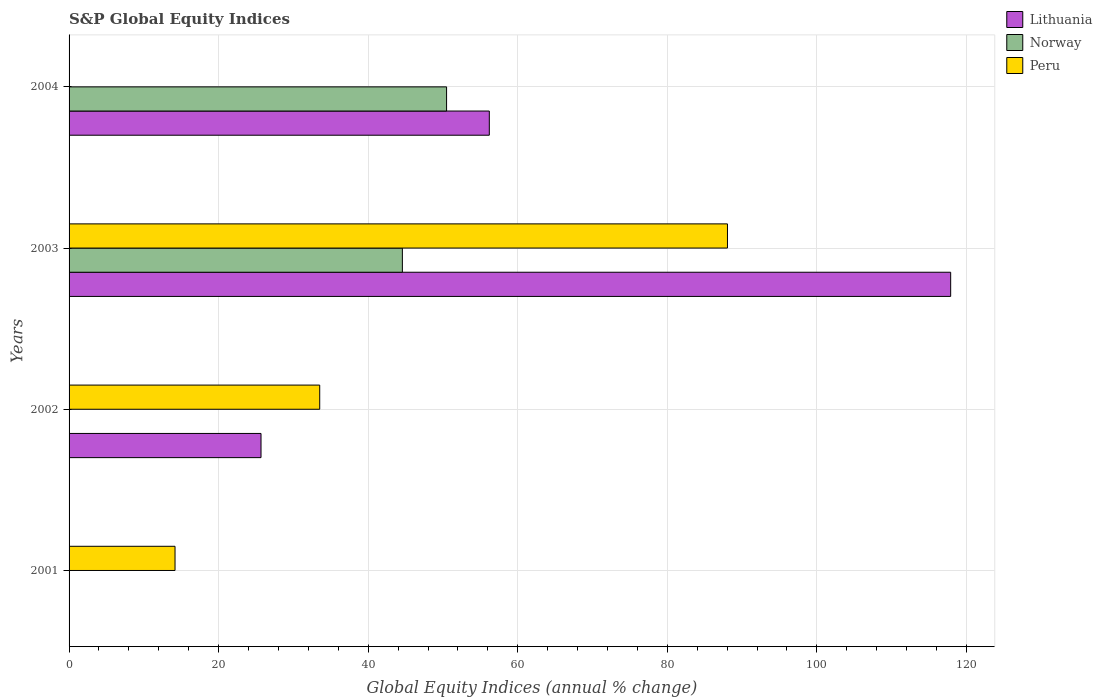Are the number of bars on each tick of the Y-axis equal?
Offer a very short reply. No. How many bars are there on the 3rd tick from the top?
Provide a short and direct response. 2. How many bars are there on the 1st tick from the bottom?
Keep it short and to the point. 1. In how many cases, is the number of bars for a given year not equal to the number of legend labels?
Give a very brief answer. 3. What is the global equity indices in Peru in 2001?
Your answer should be very brief. 14.17. Across all years, what is the maximum global equity indices in Lithuania?
Keep it short and to the point. 117.9. In which year was the global equity indices in Peru maximum?
Your answer should be very brief. 2003. What is the total global equity indices in Lithuania in the graph?
Your answer should be very brief. 199.77. What is the difference between the global equity indices in Peru in 2001 and that in 2002?
Provide a short and direct response. -19.35. What is the difference between the global equity indices in Norway in 2003 and the global equity indices in Lithuania in 2002?
Your response must be concise. 18.9. What is the average global equity indices in Peru per year?
Provide a short and direct response. 33.93. In the year 2003, what is the difference between the global equity indices in Norway and global equity indices in Lithuania?
Offer a very short reply. -73.33. Is the global equity indices in Peru in 2002 less than that in 2003?
Keep it short and to the point. Yes. What is the difference between the highest and the second highest global equity indices in Lithuania?
Your answer should be very brief. 61.7. What is the difference between the highest and the lowest global equity indices in Peru?
Your response must be concise. 88.05. In how many years, is the global equity indices in Norway greater than the average global equity indices in Norway taken over all years?
Keep it short and to the point. 2. Is the sum of the global equity indices in Peru in 2002 and 2003 greater than the maximum global equity indices in Lithuania across all years?
Make the answer very short. Yes. How many bars are there?
Offer a very short reply. 8. What is the difference between two consecutive major ticks on the X-axis?
Ensure brevity in your answer.  20. Does the graph contain any zero values?
Provide a succinct answer. Yes. Does the graph contain grids?
Make the answer very short. Yes. Where does the legend appear in the graph?
Give a very brief answer. Top right. How many legend labels are there?
Your answer should be compact. 3. How are the legend labels stacked?
Offer a terse response. Vertical. What is the title of the graph?
Provide a short and direct response. S&P Global Equity Indices. Does "Cuba" appear as one of the legend labels in the graph?
Your response must be concise. No. What is the label or title of the X-axis?
Your answer should be compact. Global Equity Indices (annual % change). What is the Global Equity Indices (annual % change) of Lithuania in 2001?
Keep it short and to the point. 0. What is the Global Equity Indices (annual % change) of Peru in 2001?
Offer a very short reply. 14.17. What is the Global Equity Indices (annual % change) of Lithuania in 2002?
Provide a short and direct response. 25.67. What is the Global Equity Indices (annual % change) in Norway in 2002?
Your response must be concise. 0. What is the Global Equity Indices (annual % change) in Peru in 2002?
Your response must be concise. 33.52. What is the Global Equity Indices (annual % change) of Lithuania in 2003?
Provide a succinct answer. 117.9. What is the Global Equity Indices (annual % change) in Norway in 2003?
Offer a very short reply. 44.57. What is the Global Equity Indices (annual % change) in Peru in 2003?
Provide a succinct answer. 88.05. What is the Global Equity Indices (annual % change) in Lithuania in 2004?
Give a very brief answer. 56.2. What is the Global Equity Indices (annual % change) of Norway in 2004?
Keep it short and to the point. 50.49. What is the Global Equity Indices (annual % change) in Peru in 2004?
Give a very brief answer. 0. Across all years, what is the maximum Global Equity Indices (annual % change) of Lithuania?
Your response must be concise. 117.9. Across all years, what is the maximum Global Equity Indices (annual % change) in Norway?
Offer a terse response. 50.49. Across all years, what is the maximum Global Equity Indices (annual % change) of Peru?
Provide a succinct answer. 88.05. Across all years, what is the minimum Global Equity Indices (annual % change) of Lithuania?
Offer a very short reply. 0. Across all years, what is the minimum Global Equity Indices (annual % change) of Peru?
Provide a short and direct response. 0. What is the total Global Equity Indices (annual % change) in Lithuania in the graph?
Provide a short and direct response. 199.77. What is the total Global Equity Indices (annual % change) of Norway in the graph?
Provide a succinct answer. 95.06. What is the total Global Equity Indices (annual % change) in Peru in the graph?
Your response must be concise. 135.74. What is the difference between the Global Equity Indices (annual % change) in Peru in 2001 and that in 2002?
Offer a very short reply. -19.35. What is the difference between the Global Equity Indices (annual % change) of Peru in 2001 and that in 2003?
Your response must be concise. -73.88. What is the difference between the Global Equity Indices (annual % change) in Lithuania in 2002 and that in 2003?
Give a very brief answer. -92.23. What is the difference between the Global Equity Indices (annual % change) in Peru in 2002 and that in 2003?
Give a very brief answer. -54.53. What is the difference between the Global Equity Indices (annual % change) of Lithuania in 2002 and that in 2004?
Your answer should be compact. -30.53. What is the difference between the Global Equity Indices (annual % change) in Lithuania in 2003 and that in 2004?
Your answer should be compact. 61.7. What is the difference between the Global Equity Indices (annual % change) of Norway in 2003 and that in 2004?
Offer a terse response. -5.91. What is the difference between the Global Equity Indices (annual % change) in Lithuania in 2002 and the Global Equity Indices (annual % change) in Norway in 2003?
Give a very brief answer. -18.9. What is the difference between the Global Equity Indices (annual % change) in Lithuania in 2002 and the Global Equity Indices (annual % change) in Peru in 2003?
Offer a very short reply. -62.38. What is the difference between the Global Equity Indices (annual % change) in Lithuania in 2002 and the Global Equity Indices (annual % change) in Norway in 2004?
Your response must be concise. -24.82. What is the difference between the Global Equity Indices (annual % change) in Lithuania in 2003 and the Global Equity Indices (annual % change) in Norway in 2004?
Offer a terse response. 67.41. What is the average Global Equity Indices (annual % change) of Lithuania per year?
Provide a short and direct response. 49.94. What is the average Global Equity Indices (annual % change) in Norway per year?
Your answer should be compact. 23.77. What is the average Global Equity Indices (annual % change) in Peru per year?
Your answer should be compact. 33.93. In the year 2002, what is the difference between the Global Equity Indices (annual % change) of Lithuania and Global Equity Indices (annual % change) of Peru?
Give a very brief answer. -7.85. In the year 2003, what is the difference between the Global Equity Indices (annual % change) of Lithuania and Global Equity Indices (annual % change) of Norway?
Offer a terse response. 73.33. In the year 2003, what is the difference between the Global Equity Indices (annual % change) of Lithuania and Global Equity Indices (annual % change) of Peru?
Ensure brevity in your answer.  29.85. In the year 2003, what is the difference between the Global Equity Indices (annual % change) of Norway and Global Equity Indices (annual % change) of Peru?
Your answer should be very brief. -43.48. In the year 2004, what is the difference between the Global Equity Indices (annual % change) of Lithuania and Global Equity Indices (annual % change) of Norway?
Offer a terse response. 5.71. What is the ratio of the Global Equity Indices (annual % change) of Peru in 2001 to that in 2002?
Provide a succinct answer. 0.42. What is the ratio of the Global Equity Indices (annual % change) of Peru in 2001 to that in 2003?
Make the answer very short. 0.16. What is the ratio of the Global Equity Indices (annual % change) in Lithuania in 2002 to that in 2003?
Your answer should be very brief. 0.22. What is the ratio of the Global Equity Indices (annual % change) of Peru in 2002 to that in 2003?
Keep it short and to the point. 0.38. What is the ratio of the Global Equity Indices (annual % change) of Lithuania in 2002 to that in 2004?
Provide a short and direct response. 0.46. What is the ratio of the Global Equity Indices (annual % change) in Lithuania in 2003 to that in 2004?
Offer a very short reply. 2.1. What is the ratio of the Global Equity Indices (annual % change) of Norway in 2003 to that in 2004?
Your answer should be very brief. 0.88. What is the difference between the highest and the second highest Global Equity Indices (annual % change) of Lithuania?
Ensure brevity in your answer.  61.7. What is the difference between the highest and the second highest Global Equity Indices (annual % change) in Peru?
Your response must be concise. 54.53. What is the difference between the highest and the lowest Global Equity Indices (annual % change) in Lithuania?
Ensure brevity in your answer.  117.9. What is the difference between the highest and the lowest Global Equity Indices (annual % change) in Norway?
Make the answer very short. 50.49. What is the difference between the highest and the lowest Global Equity Indices (annual % change) of Peru?
Offer a very short reply. 88.05. 